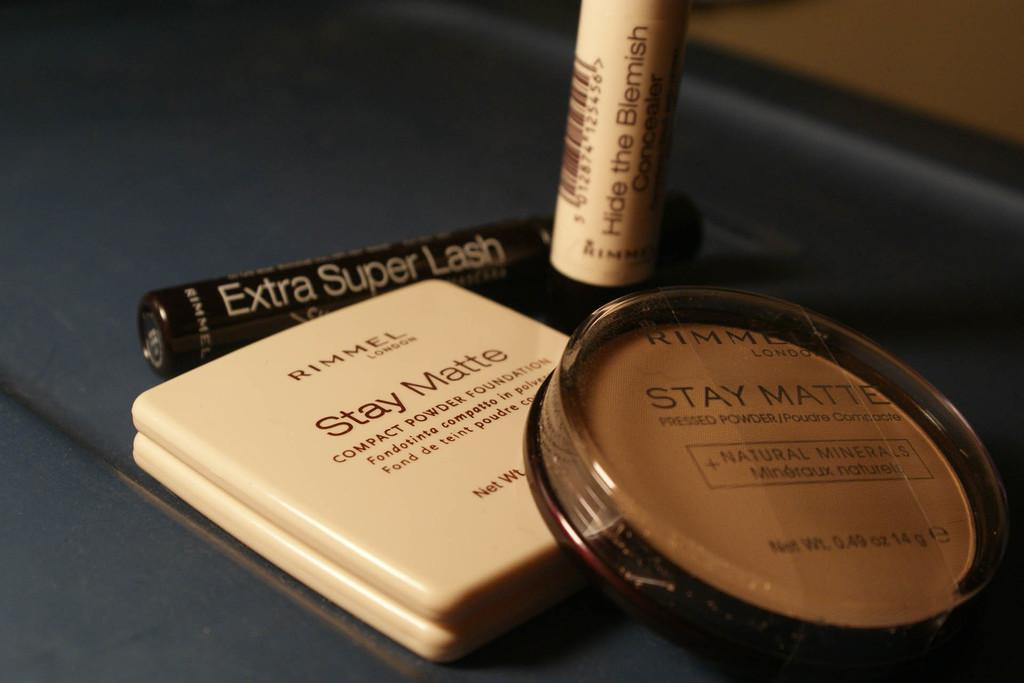<image>
Summarize the visual content of the image. a display of makeup by rimmel including compacts and mascara 